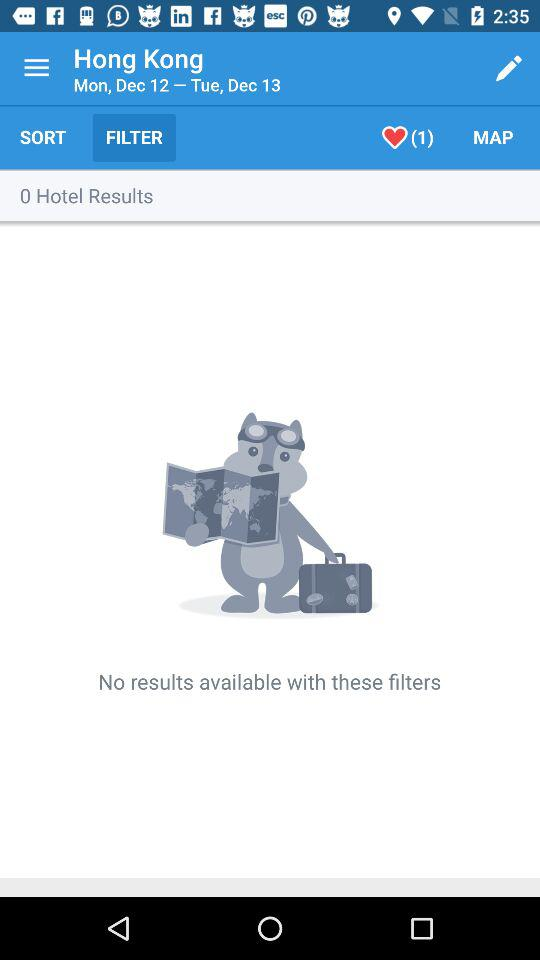How many hotels are in the results?
Answer the question using a single word or phrase. 0 